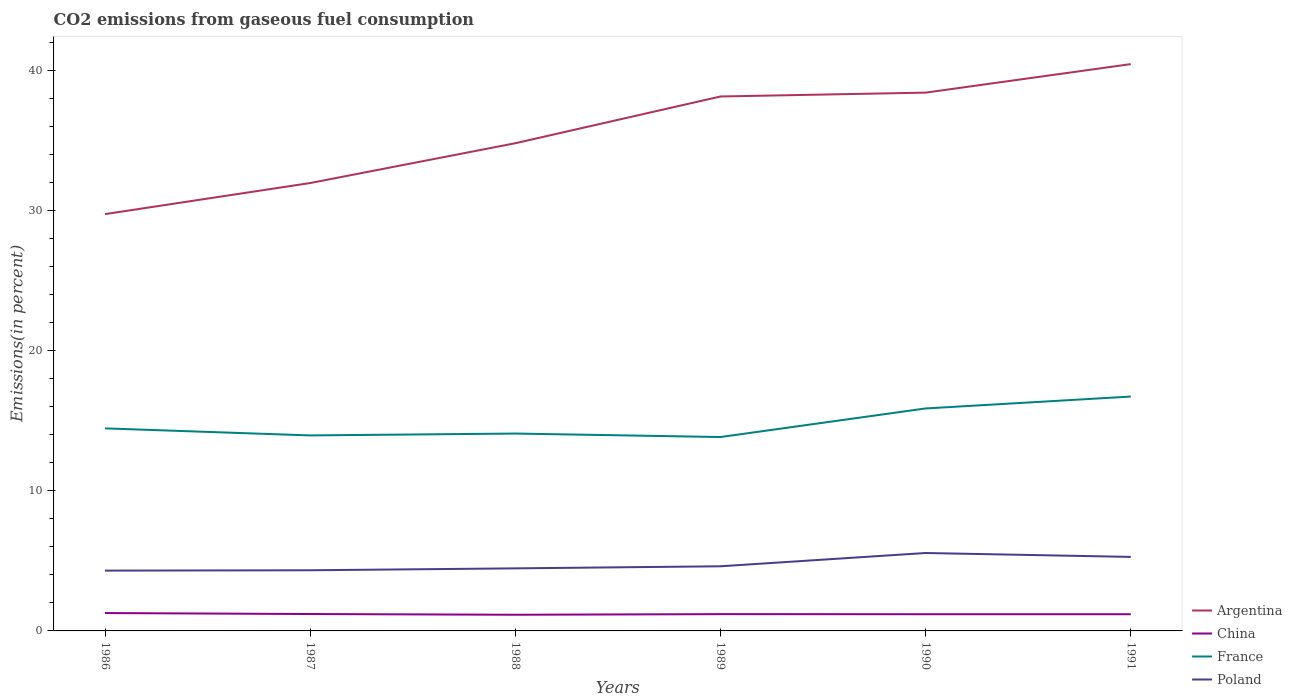How many different coloured lines are there?
Ensure brevity in your answer.  4. Is the number of lines equal to the number of legend labels?
Provide a short and direct response. Yes. Across all years, what is the maximum total CO2 emitted in Poland?
Ensure brevity in your answer.  4.3. What is the total total CO2 emitted in France in the graph?
Keep it short and to the point. 0.62. What is the difference between the highest and the second highest total CO2 emitted in China?
Keep it short and to the point. 0.12. What is the difference between the highest and the lowest total CO2 emitted in Poland?
Ensure brevity in your answer.  2. How many years are there in the graph?
Your answer should be very brief. 6. Does the graph contain any zero values?
Your response must be concise. No. Does the graph contain grids?
Your answer should be very brief. No. How many legend labels are there?
Offer a terse response. 4. How are the legend labels stacked?
Keep it short and to the point. Vertical. What is the title of the graph?
Your answer should be very brief. CO2 emissions from gaseous fuel consumption. What is the label or title of the X-axis?
Keep it short and to the point. Years. What is the label or title of the Y-axis?
Make the answer very short. Emissions(in percent). What is the Emissions(in percent) in Argentina in 1986?
Provide a succinct answer. 29.74. What is the Emissions(in percent) of China in 1986?
Your response must be concise. 1.27. What is the Emissions(in percent) in France in 1986?
Your response must be concise. 14.45. What is the Emissions(in percent) of Poland in 1986?
Give a very brief answer. 4.3. What is the Emissions(in percent) in Argentina in 1987?
Provide a short and direct response. 31.95. What is the Emissions(in percent) in China in 1987?
Keep it short and to the point. 1.2. What is the Emissions(in percent) in France in 1987?
Provide a succinct answer. 13.95. What is the Emissions(in percent) in Poland in 1987?
Your answer should be very brief. 4.33. What is the Emissions(in percent) of Argentina in 1988?
Your answer should be compact. 34.79. What is the Emissions(in percent) of China in 1988?
Give a very brief answer. 1.15. What is the Emissions(in percent) of France in 1988?
Offer a terse response. 14.08. What is the Emissions(in percent) in Poland in 1988?
Keep it short and to the point. 4.46. What is the Emissions(in percent) in Argentina in 1989?
Offer a terse response. 38.13. What is the Emissions(in percent) of China in 1989?
Keep it short and to the point. 1.2. What is the Emissions(in percent) in France in 1989?
Your answer should be compact. 13.83. What is the Emissions(in percent) in Poland in 1989?
Offer a very short reply. 4.61. What is the Emissions(in percent) of Argentina in 1990?
Provide a short and direct response. 38.4. What is the Emissions(in percent) of China in 1990?
Ensure brevity in your answer.  1.19. What is the Emissions(in percent) of France in 1990?
Provide a short and direct response. 15.87. What is the Emissions(in percent) of Poland in 1990?
Your response must be concise. 5.56. What is the Emissions(in percent) of Argentina in 1991?
Your response must be concise. 40.44. What is the Emissions(in percent) in China in 1991?
Offer a very short reply. 1.19. What is the Emissions(in percent) of France in 1991?
Keep it short and to the point. 16.72. What is the Emissions(in percent) of Poland in 1991?
Ensure brevity in your answer.  5.28. Across all years, what is the maximum Emissions(in percent) in Argentina?
Give a very brief answer. 40.44. Across all years, what is the maximum Emissions(in percent) in China?
Offer a terse response. 1.27. Across all years, what is the maximum Emissions(in percent) in France?
Provide a succinct answer. 16.72. Across all years, what is the maximum Emissions(in percent) of Poland?
Your answer should be compact. 5.56. Across all years, what is the minimum Emissions(in percent) of Argentina?
Keep it short and to the point. 29.74. Across all years, what is the minimum Emissions(in percent) in China?
Make the answer very short. 1.15. Across all years, what is the minimum Emissions(in percent) in France?
Make the answer very short. 13.83. Across all years, what is the minimum Emissions(in percent) in Poland?
Your answer should be very brief. 4.3. What is the total Emissions(in percent) in Argentina in the graph?
Give a very brief answer. 213.46. What is the total Emissions(in percent) in China in the graph?
Give a very brief answer. 7.21. What is the total Emissions(in percent) of France in the graph?
Provide a succinct answer. 88.91. What is the total Emissions(in percent) of Poland in the graph?
Offer a terse response. 28.55. What is the difference between the Emissions(in percent) in Argentina in 1986 and that in 1987?
Your response must be concise. -2.22. What is the difference between the Emissions(in percent) of China in 1986 and that in 1987?
Provide a succinct answer. 0.07. What is the difference between the Emissions(in percent) in France in 1986 and that in 1987?
Offer a terse response. 0.5. What is the difference between the Emissions(in percent) of Poland in 1986 and that in 1987?
Offer a very short reply. -0.02. What is the difference between the Emissions(in percent) in Argentina in 1986 and that in 1988?
Provide a short and direct response. -5.06. What is the difference between the Emissions(in percent) of China in 1986 and that in 1988?
Make the answer very short. 0.12. What is the difference between the Emissions(in percent) in France in 1986 and that in 1988?
Offer a very short reply. 0.37. What is the difference between the Emissions(in percent) in Poland in 1986 and that in 1988?
Give a very brief answer. -0.16. What is the difference between the Emissions(in percent) in Argentina in 1986 and that in 1989?
Provide a succinct answer. -8.39. What is the difference between the Emissions(in percent) of China in 1986 and that in 1989?
Make the answer very short. 0.08. What is the difference between the Emissions(in percent) in France in 1986 and that in 1989?
Keep it short and to the point. 0.62. What is the difference between the Emissions(in percent) in Poland in 1986 and that in 1989?
Offer a terse response. -0.31. What is the difference between the Emissions(in percent) in Argentina in 1986 and that in 1990?
Make the answer very short. -8.67. What is the difference between the Emissions(in percent) in China in 1986 and that in 1990?
Provide a short and direct response. 0.08. What is the difference between the Emissions(in percent) of France in 1986 and that in 1990?
Ensure brevity in your answer.  -1.42. What is the difference between the Emissions(in percent) of Poland in 1986 and that in 1990?
Your answer should be very brief. -1.26. What is the difference between the Emissions(in percent) of Argentina in 1986 and that in 1991?
Your answer should be compact. -10.7. What is the difference between the Emissions(in percent) in China in 1986 and that in 1991?
Ensure brevity in your answer.  0.08. What is the difference between the Emissions(in percent) in France in 1986 and that in 1991?
Your answer should be very brief. -2.27. What is the difference between the Emissions(in percent) of Poland in 1986 and that in 1991?
Provide a short and direct response. -0.98. What is the difference between the Emissions(in percent) of Argentina in 1987 and that in 1988?
Provide a succinct answer. -2.84. What is the difference between the Emissions(in percent) of China in 1987 and that in 1988?
Offer a very short reply. 0.05. What is the difference between the Emissions(in percent) in France in 1987 and that in 1988?
Provide a succinct answer. -0.13. What is the difference between the Emissions(in percent) of Poland in 1987 and that in 1988?
Give a very brief answer. -0.14. What is the difference between the Emissions(in percent) in Argentina in 1987 and that in 1989?
Ensure brevity in your answer.  -6.17. What is the difference between the Emissions(in percent) in China in 1987 and that in 1989?
Your answer should be compact. 0.01. What is the difference between the Emissions(in percent) of France in 1987 and that in 1989?
Your answer should be compact. 0.11. What is the difference between the Emissions(in percent) in Poland in 1987 and that in 1989?
Ensure brevity in your answer.  -0.28. What is the difference between the Emissions(in percent) in Argentina in 1987 and that in 1990?
Provide a short and direct response. -6.45. What is the difference between the Emissions(in percent) of China in 1987 and that in 1990?
Provide a short and direct response. 0.01. What is the difference between the Emissions(in percent) of France in 1987 and that in 1990?
Your answer should be very brief. -1.92. What is the difference between the Emissions(in percent) of Poland in 1987 and that in 1990?
Ensure brevity in your answer.  -1.23. What is the difference between the Emissions(in percent) in Argentina in 1987 and that in 1991?
Keep it short and to the point. -8.49. What is the difference between the Emissions(in percent) of China in 1987 and that in 1991?
Give a very brief answer. 0.01. What is the difference between the Emissions(in percent) of France in 1987 and that in 1991?
Give a very brief answer. -2.77. What is the difference between the Emissions(in percent) of Poland in 1987 and that in 1991?
Offer a very short reply. -0.95. What is the difference between the Emissions(in percent) in Argentina in 1988 and that in 1989?
Offer a very short reply. -3.33. What is the difference between the Emissions(in percent) of China in 1988 and that in 1989?
Ensure brevity in your answer.  -0.04. What is the difference between the Emissions(in percent) in France in 1988 and that in 1989?
Ensure brevity in your answer.  0.25. What is the difference between the Emissions(in percent) of Poland in 1988 and that in 1989?
Your answer should be very brief. -0.15. What is the difference between the Emissions(in percent) in Argentina in 1988 and that in 1990?
Ensure brevity in your answer.  -3.61. What is the difference between the Emissions(in percent) in China in 1988 and that in 1990?
Ensure brevity in your answer.  -0.04. What is the difference between the Emissions(in percent) in France in 1988 and that in 1990?
Provide a succinct answer. -1.79. What is the difference between the Emissions(in percent) of Poland in 1988 and that in 1990?
Keep it short and to the point. -1.1. What is the difference between the Emissions(in percent) of Argentina in 1988 and that in 1991?
Give a very brief answer. -5.64. What is the difference between the Emissions(in percent) of China in 1988 and that in 1991?
Keep it short and to the point. -0.04. What is the difference between the Emissions(in percent) of France in 1988 and that in 1991?
Keep it short and to the point. -2.64. What is the difference between the Emissions(in percent) of Poland in 1988 and that in 1991?
Your response must be concise. -0.82. What is the difference between the Emissions(in percent) in Argentina in 1989 and that in 1990?
Ensure brevity in your answer.  -0.28. What is the difference between the Emissions(in percent) in China in 1989 and that in 1990?
Keep it short and to the point. 0.01. What is the difference between the Emissions(in percent) of France in 1989 and that in 1990?
Your answer should be very brief. -2.04. What is the difference between the Emissions(in percent) in Poland in 1989 and that in 1990?
Provide a short and direct response. -0.95. What is the difference between the Emissions(in percent) of Argentina in 1989 and that in 1991?
Offer a very short reply. -2.31. What is the difference between the Emissions(in percent) of China in 1989 and that in 1991?
Make the answer very short. 0.01. What is the difference between the Emissions(in percent) in France in 1989 and that in 1991?
Your answer should be compact. -2.89. What is the difference between the Emissions(in percent) of Poland in 1989 and that in 1991?
Your response must be concise. -0.67. What is the difference between the Emissions(in percent) in Argentina in 1990 and that in 1991?
Your answer should be very brief. -2.03. What is the difference between the Emissions(in percent) of China in 1990 and that in 1991?
Your answer should be very brief. -0. What is the difference between the Emissions(in percent) in France in 1990 and that in 1991?
Give a very brief answer. -0.85. What is the difference between the Emissions(in percent) of Poland in 1990 and that in 1991?
Offer a very short reply. 0.28. What is the difference between the Emissions(in percent) of Argentina in 1986 and the Emissions(in percent) of China in 1987?
Ensure brevity in your answer.  28.53. What is the difference between the Emissions(in percent) in Argentina in 1986 and the Emissions(in percent) in France in 1987?
Ensure brevity in your answer.  15.79. What is the difference between the Emissions(in percent) of Argentina in 1986 and the Emissions(in percent) of Poland in 1987?
Make the answer very short. 25.41. What is the difference between the Emissions(in percent) of China in 1986 and the Emissions(in percent) of France in 1987?
Give a very brief answer. -12.67. What is the difference between the Emissions(in percent) in China in 1986 and the Emissions(in percent) in Poland in 1987?
Provide a succinct answer. -3.05. What is the difference between the Emissions(in percent) in France in 1986 and the Emissions(in percent) in Poland in 1987?
Your answer should be compact. 10.12. What is the difference between the Emissions(in percent) of Argentina in 1986 and the Emissions(in percent) of China in 1988?
Provide a succinct answer. 28.58. What is the difference between the Emissions(in percent) in Argentina in 1986 and the Emissions(in percent) in France in 1988?
Ensure brevity in your answer.  15.66. What is the difference between the Emissions(in percent) in Argentina in 1986 and the Emissions(in percent) in Poland in 1988?
Make the answer very short. 25.27. What is the difference between the Emissions(in percent) in China in 1986 and the Emissions(in percent) in France in 1988?
Your answer should be compact. -12.81. What is the difference between the Emissions(in percent) in China in 1986 and the Emissions(in percent) in Poland in 1988?
Provide a succinct answer. -3.19. What is the difference between the Emissions(in percent) of France in 1986 and the Emissions(in percent) of Poland in 1988?
Make the answer very short. 9.99. What is the difference between the Emissions(in percent) of Argentina in 1986 and the Emissions(in percent) of China in 1989?
Ensure brevity in your answer.  28.54. What is the difference between the Emissions(in percent) in Argentina in 1986 and the Emissions(in percent) in France in 1989?
Provide a succinct answer. 15.9. What is the difference between the Emissions(in percent) in Argentina in 1986 and the Emissions(in percent) in Poland in 1989?
Provide a short and direct response. 25.13. What is the difference between the Emissions(in percent) in China in 1986 and the Emissions(in percent) in France in 1989?
Offer a terse response. -12.56. What is the difference between the Emissions(in percent) in China in 1986 and the Emissions(in percent) in Poland in 1989?
Make the answer very short. -3.34. What is the difference between the Emissions(in percent) in France in 1986 and the Emissions(in percent) in Poland in 1989?
Ensure brevity in your answer.  9.84. What is the difference between the Emissions(in percent) in Argentina in 1986 and the Emissions(in percent) in China in 1990?
Your response must be concise. 28.55. What is the difference between the Emissions(in percent) of Argentina in 1986 and the Emissions(in percent) of France in 1990?
Give a very brief answer. 13.86. What is the difference between the Emissions(in percent) of Argentina in 1986 and the Emissions(in percent) of Poland in 1990?
Offer a very short reply. 24.18. What is the difference between the Emissions(in percent) of China in 1986 and the Emissions(in percent) of France in 1990?
Your answer should be compact. -14.6. What is the difference between the Emissions(in percent) in China in 1986 and the Emissions(in percent) in Poland in 1990?
Your answer should be very brief. -4.28. What is the difference between the Emissions(in percent) in France in 1986 and the Emissions(in percent) in Poland in 1990?
Your answer should be very brief. 8.89. What is the difference between the Emissions(in percent) in Argentina in 1986 and the Emissions(in percent) in China in 1991?
Keep it short and to the point. 28.55. What is the difference between the Emissions(in percent) of Argentina in 1986 and the Emissions(in percent) of France in 1991?
Your response must be concise. 13.02. What is the difference between the Emissions(in percent) of Argentina in 1986 and the Emissions(in percent) of Poland in 1991?
Provide a succinct answer. 24.46. What is the difference between the Emissions(in percent) of China in 1986 and the Emissions(in percent) of France in 1991?
Your answer should be very brief. -15.45. What is the difference between the Emissions(in percent) in China in 1986 and the Emissions(in percent) in Poland in 1991?
Your answer should be very brief. -4.01. What is the difference between the Emissions(in percent) in France in 1986 and the Emissions(in percent) in Poland in 1991?
Give a very brief answer. 9.17. What is the difference between the Emissions(in percent) of Argentina in 1987 and the Emissions(in percent) of China in 1988?
Your response must be concise. 30.8. What is the difference between the Emissions(in percent) of Argentina in 1987 and the Emissions(in percent) of France in 1988?
Make the answer very short. 17.87. What is the difference between the Emissions(in percent) in Argentina in 1987 and the Emissions(in percent) in Poland in 1988?
Your answer should be very brief. 27.49. What is the difference between the Emissions(in percent) in China in 1987 and the Emissions(in percent) in France in 1988?
Give a very brief answer. -12.88. What is the difference between the Emissions(in percent) in China in 1987 and the Emissions(in percent) in Poland in 1988?
Ensure brevity in your answer.  -3.26. What is the difference between the Emissions(in percent) in France in 1987 and the Emissions(in percent) in Poland in 1988?
Your answer should be compact. 9.48. What is the difference between the Emissions(in percent) in Argentina in 1987 and the Emissions(in percent) in China in 1989?
Your answer should be compact. 30.76. What is the difference between the Emissions(in percent) of Argentina in 1987 and the Emissions(in percent) of France in 1989?
Your answer should be compact. 18.12. What is the difference between the Emissions(in percent) in Argentina in 1987 and the Emissions(in percent) in Poland in 1989?
Provide a short and direct response. 27.34. What is the difference between the Emissions(in percent) of China in 1987 and the Emissions(in percent) of France in 1989?
Keep it short and to the point. -12.63. What is the difference between the Emissions(in percent) of China in 1987 and the Emissions(in percent) of Poland in 1989?
Your answer should be very brief. -3.41. What is the difference between the Emissions(in percent) of France in 1987 and the Emissions(in percent) of Poland in 1989?
Give a very brief answer. 9.34. What is the difference between the Emissions(in percent) of Argentina in 1987 and the Emissions(in percent) of China in 1990?
Your answer should be compact. 30.76. What is the difference between the Emissions(in percent) of Argentina in 1987 and the Emissions(in percent) of France in 1990?
Ensure brevity in your answer.  16.08. What is the difference between the Emissions(in percent) of Argentina in 1987 and the Emissions(in percent) of Poland in 1990?
Offer a very short reply. 26.39. What is the difference between the Emissions(in percent) of China in 1987 and the Emissions(in percent) of France in 1990?
Your answer should be very brief. -14.67. What is the difference between the Emissions(in percent) in China in 1987 and the Emissions(in percent) in Poland in 1990?
Offer a very short reply. -4.35. What is the difference between the Emissions(in percent) in France in 1987 and the Emissions(in percent) in Poland in 1990?
Ensure brevity in your answer.  8.39. What is the difference between the Emissions(in percent) of Argentina in 1987 and the Emissions(in percent) of China in 1991?
Make the answer very short. 30.76. What is the difference between the Emissions(in percent) of Argentina in 1987 and the Emissions(in percent) of France in 1991?
Your answer should be very brief. 15.23. What is the difference between the Emissions(in percent) of Argentina in 1987 and the Emissions(in percent) of Poland in 1991?
Provide a succinct answer. 26.67. What is the difference between the Emissions(in percent) in China in 1987 and the Emissions(in percent) in France in 1991?
Your response must be concise. -15.52. What is the difference between the Emissions(in percent) in China in 1987 and the Emissions(in percent) in Poland in 1991?
Give a very brief answer. -4.08. What is the difference between the Emissions(in percent) in France in 1987 and the Emissions(in percent) in Poland in 1991?
Your answer should be compact. 8.67. What is the difference between the Emissions(in percent) of Argentina in 1988 and the Emissions(in percent) of China in 1989?
Your response must be concise. 33.6. What is the difference between the Emissions(in percent) of Argentina in 1988 and the Emissions(in percent) of France in 1989?
Give a very brief answer. 20.96. What is the difference between the Emissions(in percent) in Argentina in 1988 and the Emissions(in percent) in Poland in 1989?
Make the answer very short. 30.18. What is the difference between the Emissions(in percent) in China in 1988 and the Emissions(in percent) in France in 1989?
Offer a terse response. -12.68. What is the difference between the Emissions(in percent) in China in 1988 and the Emissions(in percent) in Poland in 1989?
Make the answer very short. -3.46. What is the difference between the Emissions(in percent) in France in 1988 and the Emissions(in percent) in Poland in 1989?
Make the answer very short. 9.47. What is the difference between the Emissions(in percent) in Argentina in 1988 and the Emissions(in percent) in China in 1990?
Give a very brief answer. 33.6. What is the difference between the Emissions(in percent) in Argentina in 1988 and the Emissions(in percent) in France in 1990?
Offer a very short reply. 18.92. What is the difference between the Emissions(in percent) of Argentina in 1988 and the Emissions(in percent) of Poland in 1990?
Offer a very short reply. 29.24. What is the difference between the Emissions(in percent) in China in 1988 and the Emissions(in percent) in France in 1990?
Offer a terse response. -14.72. What is the difference between the Emissions(in percent) of China in 1988 and the Emissions(in percent) of Poland in 1990?
Your answer should be very brief. -4.41. What is the difference between the Emissions(in percent) in France in 1988 and the Emissions(in percent) in Poland in 1990?
Offer a very short reply. 8.52. What is the difference between the Emissions(in percent) in Argentina in 1988 and the Emissions(in percent) in China in 1991?
Offer a very short reply. 33.6. What is the difference between the Emissions(in percent) in Argentina in 1988 and the Emissions(in percent) in France in 1991?
Your response must be concise. 18.07. What is the difference between the Emissions(in percent) of Argentina in 1988 and the Emissions(in percent) of Poland in 1991?
Make the answer very short. 29.51. What is the difference between the Emissions(in percent) in China in 1988 and the Emissions(in percent) in France in 1991?
Provide a short and direct response. -15.57. What is the difference between the Emissions(in percent) in China in 1988 and the Emissions(in percent) in Poland in 1991?
Keep it short and to the point. -4.13. What is the difference between the Emissions(in percent) in France in 1988 and the Emissions(in percent) in Poland in 1991?
Offer a very short reply. 8.8. What is the difference between the Emissions(in percent) in Argentina in 1989 and the Emissions(in percent) in China in 1990?
Provide a short and direct response. 36.94. What is the difference between the Emissions(in percent) of Argentina in 1989 and the Emissions(in percent) of France in 1990?
Provide a succinct answer. 22.26. What is the difference between the Emissions(in percent) of Argentina in 1989 and the Emissions(in percent) of Poland in 1990?
Ensure brevity in your answer.  32.57. What is the difference between the Emissions(in percent) of China in 1989 and the Emissions(in percent) of France in 1990?
Make the answer very short. -14.67. What is the difference between the Emissions(in percent) in China in 1989 and the Emissions(in percent) in Poland in 1990?
Your response must be concise. -4.36. What is the difference between the Emissions(in percent) in France in 1989 and the Emissions(in percent) in Poland in 1990?
Your response must be concise. 8.27. What is the difference between the Emissions(in percent) in Argentina in 1989 and the Emissions(in percent) in China in 1991?
Keep it short and to the point. 36.94. What is the difference between the Emissions(in percent) of Argentina in 1989 and the Emissions(in percent) of France in 1991?
Offer a terse response. 21.41. What is the difference between the Emissions(in percent) in Argentina in 1989 and the Emissions(in percent) in Poland in 1991?
Make the answer very short. 32.85. What is the difference between the Emissions(in percent) of China in 1989 and the Emissions(in percent) of France in 1991?
Make the answer very short. -15.52. What is the difference between the Emissions(in percent) of China in 1989 and the Emissions(in percent) of Poland in 1991?
Provide a short and direct response. -4.08. What is the difference between the Emissions(in percent) in France in 1989 and the Emissions(in percent) in Poland in 1991?
Keep it short and to the point. 8.55. What is the difference between the Emissions(in percent) of Argentina in 1990 and the Emissions(in percent) of China in 1991?
Ensure brevity in your answer.  37.21. What is the difference between the Emissions(in percent) in Argentina in 1990 and the Emissions(in percent) in France in 1991?
Your answer should be very brief. 21.68. What is the difference between the Emissions(in percent) in Argentina in 1990 and the Emissions(in percent) in Poland in 1991?
Provide a short and direct response. 33.12. What is the difference between the Emissions(in percent) of China in 1990 and the Emissions(in percent) of France in 1991?
Offer a very short reply. -15.53. What is the difference between the Emissions(in percent) of China in 1990 and the Emissions(in percent) of Poland in 1991?
Give a very brief answer. -4.09. What is the difference between the Emissions(in percent) of France in 1990 and the Emissions(in percent) of Poland in 1991?
Provide a succinct answer. 10.59. What is the average Emissions(in percent) in Argentina per year?
Your answer should be very brief. 35.58. What is the average Emissions(in percent) in China per year?
Make the answer very short. 1.2. What is the average Emissions(in percent) of France per year?
Your answer should be very brief. 14.82. What is the average Emissions(in percent) of Poland per year?
Provide a short and direct response. 4.76. In the year 1986, what is the difference between the Emissions(in percent) in Argentina and Emissions(in percent) in China?
Make the answer very short. 28.46. In the year 1986, what is the difference between the Emissions(in percent) in Argentina and Emissions(in percent) in France?
Make the answer very short. 15.29. In the year 1986, what is the difference between the Emissions(in percent) in Argentina and Emissions(in percent) in Poland?
Your response must be concise. 25.43. In the year 1986, what is the difference between the Emissions(in percent) in China and Emissions(in percent) in France?
Keep it short and to the point. -13.18. In the year 1986, what is the difference between the Emissions(in percent) of China and Emissions(in percent) of Poland?
Offer a very short reply. -3.03. In the year 1986, what is the difference between the Emissions(in percent) in France and Emissions(in percent) in Poland?
Your response must be concise. 10.15. In the year 1987, what is the difference between the Emissions(in percent) of Argentina and Emissions(in percent) of China?
Keep it short and to the point. 30.75. In the year 1987, what is the difference between the Emissions(in percent) in Argentina and Emissions(in percent) in France?
Your response must be concise. 18.01. In the year 1987, what is the difference between the Emissions(in percent) of Argentina and Emissions(in percent) of Poland?
Your answer should be very brief. 27.63. In the year 1987, what is the difference between the Emissions(in percent) of China and Emissions(in percent) of France?
Provide a short and direct response. -12.74. In the year 1987, what is the difference between the Emissions(in percent) in China and Emissions(in percent) in Poland?
Provide a succinct answer. -3.12. In the year 1987, what is the difference between the Emissions(in percent) of France and Emissions(in percent) of Poland?
Give a very brief answer. 9.62. In the year 1988, what is the difference between the Emissions(in percent) in Argentina and Emissions(in percent) in China?
Offer a terse response. 33.64. In the year 1988, what is the difference between the Emissions(in percent) in Argentina and Emissions(in percent) in France?
Give a very brief answer. 20.71. In the year 1988, what is the difference between the Emissions(in percent) in Argentina and Emissions(in percent) in Poland?
Keep it short and to the point. 30.33. In the year 1988, what is the difference between the Emissions(in percent) in China and Emissions(in percent) in France?
Your answer should be very brief. -12.93. In the year 1988, what is the difference between the Emissions(in percent) of China and Emissions(in percent) of Poland?
Your response must be concise. -3.31. In the year 1988, what is the difference between the Emissions(in percent) of France and Emissions(in percent) of Poland?
Give a very brief answer. 9.62. In the year 1989, what is the difference between the Emissions(in percent) of Argentina and Emissions(in percent) of China?
Your answer should be compact. 36.93. In the year 1989, what is the difference between the Emissions(in percent) of Argentina and Emissions(in percent) of France?
Your answer should be compact. 24.3. In the year 1989, what is the difference between the Emissions(in percent) in Argentina and Emissions(in percent) in Poland?
Ensure brevity in your answer.  33.52. In the year 1989, what is the difference between the Emissions(in percent) in China and Emissions(in percent) in France?
Offer a terse response. -12.64. In the year 1989, what is the difference between the Emissions(in percent) in China and Emissions(in percent) in Poland?
Offer a very short reply. -3.41. In the year 1989, what is the difference between the Emissions(in percent) of France and Emissions(in percent) of Poland?
Your response must be concise. 9.22. In the year 1990, what is the difference between the Emissions(in percent) of Argentina and Emissions(in percent) of China?
Keep it short and to the point. 37.21. In the year 1990, what is the difference between the Emissions(in percent) in Argentina and Emissions(in percent) in France?
Provide a short and direct response. 22.53. In the year 1990, what is the difference between the Emissions(in percent) in Argentina and Emissions(in percent) in Poland?
Keep it short and to the point. 32.85. In the year 1990, what is the difference between the Emissions(in percent) in China and Emissions(in percent) in France?
Offer a very short reply. -14.68. In the year 1990, what is the difference between the Emissions(in percent) in China and Emissions(in percent) in Poland?
Provide a short and direct response. -4.37. In the year 1990, what is the difference between the Emissions(in percent) of France and Emissions(in percent) of Poland?
Your answer should be compact. 10.31. In the year 1991, what is the difference between the Emissions(in percent) of Argentina and Emissions(in percent) of China?
Your answer should be very brief. 39.25. In the year 1991, what is the difference between the Emissions(in percent) in Argentina and Emissions(in percent) in France?
Ensure brevity in your answer.  23.72. In the year 1991, what is the difference between the Emissions(in percent) in Argentina and Emissions(in percent) in Poland?
Make the answer very short. 35.16. In the year 1991, what is the difference between the Emissions(in percent) in China and Emissions(in percent) in France?
Your response must be concise. -15.53. In the year 1991, what is the difference between the Emissions(in percent) of China and Emissions(in percent) of Poland?
Offer a very short reply. -4.09. In the year 1991, what is the difference between the Emissions(in percent) in France and Emissions(in percent) in Poland?
Offer a terse response. 11.44. What is the ratio of the Emissions(in percent) in Argentina in 1986 to that in 1987?
Provide a short and direct response. 0.93. What is the ratio of the Emissions(in percent) of China in 1986 to that in 1987?
Ensure brevity in your answer.  1.06. What is the ratio of the Emissions(in percent) in France in 1986 to that in 1987?
Ensure brevity in your answer.  1.04. What is the ratio of the Emissions(in percent) in Argentina in 1986 to that in 1988?
Your answer should be very brief. 0.85. What is the ratio of the Emissions(in percent) of China in 1986 to that in 1988?
Offer a terse response. 1.1. What is the ratio of the Emissions(in percent) in France in 1986 to that in 1988?
Keep it short and to the point. 1.03. What is the ratio of the Emissions(in percent) of Poland in 1986 to that in 1988?
Your response must be concise. 0.96. What is the ratio of the Emissions(in percent) of Argentina in 1986 to that in 1989?
Offer a terse response. 0.78. What is the ratio of the Emissions(in percent) in China in 1986 to that in 1989?
Ensure brevity in your answer.  1.06. What is the ratio of the Emissions(in percent) in France in 1986 to that in 1989?
Your answer should be compact. 1.04. What is the ratio of the Emissions(in percent) of Poland in 1986 to that in 1989?
Offer a very short reply. 0.93. What is the ratio of the Emissions(in percent) in Argentina in 1986 to that in 1990?
Keep it short and to the point. 0.77. What is the ratio of the Emissions(in percent) of China in 1986 to that in 1990?
Provide a short and direct response. 1.07. What is the ratio of the Emissions(in percent) in France in 1986 to that in 1990?
Provide a succinct answer. 0.91. What is the ratio of the Emissions(in percent) of Poland in 1986 to that in 1990?
Your response must be concise. 0.77. What is the ratio of the Emissions(in percent) in Argentina in 1986 to that in 1991?
Offer a very short reply. 0.74. What is the ratio of the Emissions(in percent) in China in 1986 to that in 1991?
Provide a short and direct response. 1.07. What is the ratio of the Emissions(in percent) of France in 1986 to that in 1991?
Offer a very short reply. 0.86. What is the ratio of the Emissions(in percent) of Poland in 1986 to that in 1991?
Ensure brevity in your answer.  0.81. What is the ratio of the Emissions(in percent) of Argentina in 1987 to that in 1988?
Your answer should be very brief. 0.92. What is the ratio of the Emissions(in percent) in China in 1987 to that in 1988?
Provide a short and direct response. 1.04. What is the ratio of the Emissions(in percent) in Poland in 1987 to that in 1988?
Provide a succinct answer. 0.97. What is the ratio of the Emissions(in percent) in Argentina in 1987 to that in 1989?
Provide a short and direct response. 0.84. What is the ratio of the Emissions(in percent) of China in 1987 to that in 1989?
Your answer should be compact. 1.01. What is the ratio of the Emissions(in percent) in France in 1987 to that in 1989?
Provide a short and direct response. 1.01. What is the ratio of the Emissions(in percent) of Poland in 1987 to that in 1989?
Make the answer very short. 0.94. What is the ratio of the Emissions(in percent) in Argentina in 1987 to that in 1990?
Your answer should be very brief. 0.83. What is the ratio of the Emissions(in percent) of China in 1987 to that in 1990?
Offer a terse response. 1.01. What is the ratio of the Emissions(in percent) of France in 1987 to that in 1990?
Offer a terse response. 0.88. What is the ratio of the Emissions(in percent) of Poland in 1987 to that in 1990?
Your answer should be very brief. 0.78. What is the ratio of the Emissions(in percent) of Argentina in 1987 to that in 1991?
Provide a succinct answer. 0.79. What is the ratio of the Emissions(in percent) in China in 1987 to that in 1991?
Give a very brief answer. 1.01. What is the ratio of the Emissions(in percent) of France in 1987 to that in 1991?
Offer a very short reply. 0.83. What is the ratio of the Emissions(in percent) in Poland in 1987 to that in 1991?
Your answer should be very brief. 0.82. What is the ratio of the Emissions(in percent) in Argentina in 1988 to that in 1989?
Keep it short and to the point. 0.91. What is the ratio of the Emissions(in percent) in China in 1988 to that in 1989?
Make the answer very short. 0.96. What is the ratio of the Emissions(in percent) of France in 1988 to that in 1989?
Keep it short and to the point. 1.02. What is the ratio of the Emissions(in percent) of Poland in 1988 to that in 1989?
Offer a very short reply. 0.97. What is the ratio of the Emissions(in percent) of Argentina in 1988 to that in 1990?
Provide a succinct answer. 0.91. What is the ratio of the Emissions(in percent) in France in 1988 to that in 1990?
Your answer should be compact. 0.89. What is the ratio of the Emissions(in percent) of Poland in 1988 to that in 1990?
Provide a succinct answer. 0.8. What is the ratio of the Emissions(in percent) in Argentina in 1988 to that in 1991?
Make the answer very short. 0.86. What is the ratio of the Emissions(in percent) of China in 1988 to that in 1991?
Give a very brief answer. 0.97. What is the ratio of the Emissions(in percent) of France in 1988 to that in 1991?
Make the answer very short. 0.84. What is the ratio of the Emissions(in percent) in Poland in 1988 to that in 1991?
Provide a short and direct response. 0.85. What is the ratio of the Emissions(in percent) of France in 1989 to that in 1990?
Your answer should be compact. 0.87. What is the ratio of the Emissions(in percent) in Poland in 1989 to that in 1990?
Your response must be concise. 0.83. What is the ratio of the Emissions(in percent) of Argentina in 1989 to that in 1991?
Keep it short and to the point. 0.94. What is the ratio of the Emissions(in percent) of China in 1989 to that in 1991?
Offer a terse response. 1. What is the ratio of the Emissions(in percent) of France in 1989 to that in 1991?
Give a very brief answer. 0.83. What is the ratio of the Emissions(in percent) in Poland in 1989 to that in 1991?
Make the answer very short. 0.87. What is the ratio of the Emissions(in percent) in Argentina in 1990 to that in 1991?
Keep it short and to the point. 0.95. What is the ratio of the Emissions(in percent) in China in 1990 to that in 1991?
Provide a succinct answer. 1. What is the ratio of the Emissions(in percent) in France in 1990 to that in 1991?
Your answer should be very brief. 0.95. What is the ratio of the Emissions(in percent) of Poland in 1990 to that in 1991?
Ensure brevity in your answer.  1.05. What is the difference between the highest and the second highest Emissions(in percent) of Argentina?
Provide a short and direct response. 2.03. What is the difference between the highest and the second highest Emissions(in percent) of China?
Provide a short and direct response. 0.07. What is the difference between the highest and the second highest Emissions(in percent) in France?
Offer a very short reply. 0.85. What is the difference between the highest and the second highest Emissions(in percent) in Poland?
Provide a succinct answer. 0.28. What is the difference between the highest and the lowest Emissions(in percent) of Argentina?
Keep it short and to the point. 10.7. What is the difference between the highest and the lowest Emissions(in percent) of China?
Keep it short and to the point. 0.12. What is the difference between the highest and the lowest Emissions(in percent) of France?
Make the answer very short. 2.89. What is the difference between the highest and the lowest Emissions(in percent) in Poland?
Give a very brief answer. 1.26. 